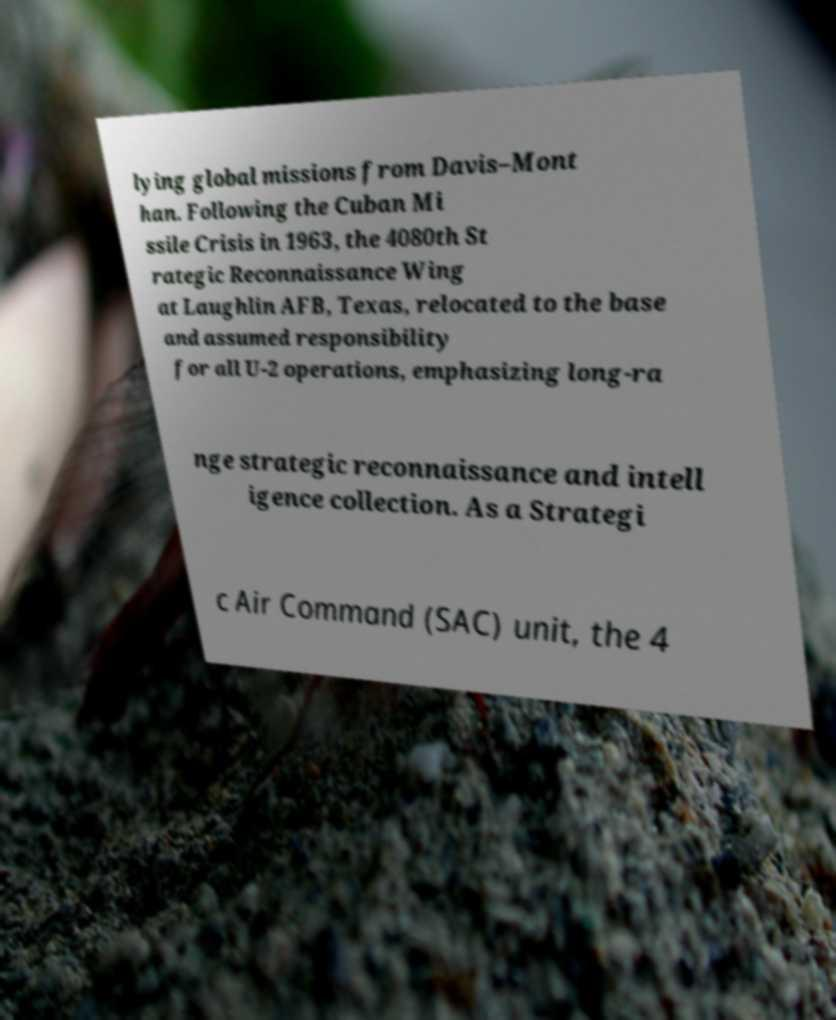Please identify and transcribe the text found in this image. lying global missions from Davis–Mont han. Following the Cuban Mi ssile Crisis in 1963, the 4080th St rategic Reconnaissance Wing at Laughlin AFB, Texas, relocated to the base and assumed responsibility for all U-2 operations, emphasizing long-ra nge strategic reconnaissance and intell igence collection. As a Strategi c Air Command (SAC) unit, the 4 